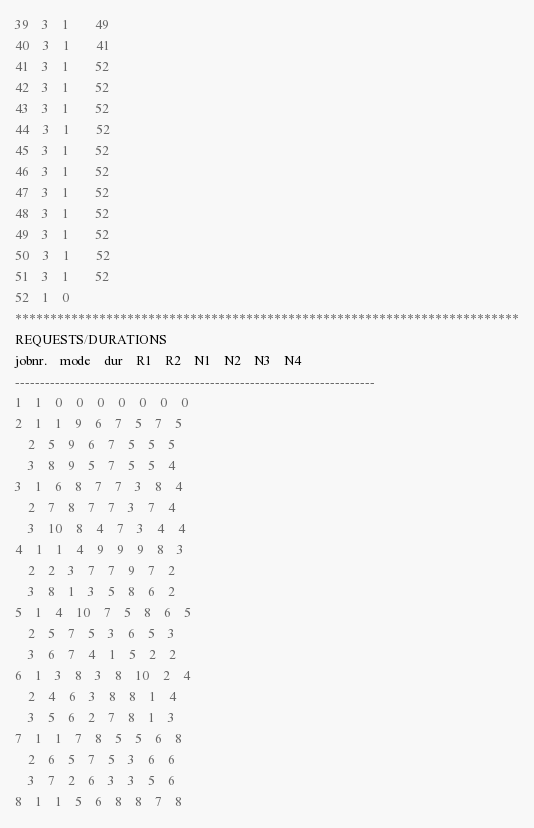<code> <loc_0><loc_0><loc_500><loc_500><_ObjectiveC_>39	3	1		49 
40	3	1		41 
41	3	1		52 
42	3	1		52 
43	3	1		52 
44	3	1		52 
45	3	1		52 
46	3	1		52 
47	3	1		52 
48	3	1		52 
49	3	1		52 
50	3	1		52 
51	3	1		52 
52	1	0		
************************************************************************
REQUESTS/DURATIONS
jobnr.	mode	dur	R1	R2	N1	N2	N3	N4	
------------------------------------------------------------------------
1	1	0	0	0	0	0	0	0	
2	1	1	9	6	7	5	7	5	
	2	5	9	6	7	5	5	5	
	3	8	9	5	7	5	5	4	
3	1	6	8	7	7	3	8	4	
	2	7	8	7	7	3	7	4	
	3	10	8	4	7	3	4	4	
4	1	1	4	9	9	9	8	3	
	2	2	3	7	7	9	7	2	
	3	8	1	3	5	8	6	2	
5	1	4	10	7	5	8	6	5	
	2	5	7	5	3	6	5	3	
	3	6	7	4	1	5	2	2	
6	1	3	8	3	8	10	2	4	
	2	4	6	3	8	8	1	4	
	3	5	6	2	7	8	1	3	
7	1	1	7	8	5	5	6	8	
	2	6	5	7	5	3	6	6	
	3	7	2	6	3	3	5	6	
8	1	1	5	6	8	8	7	8	</code> 